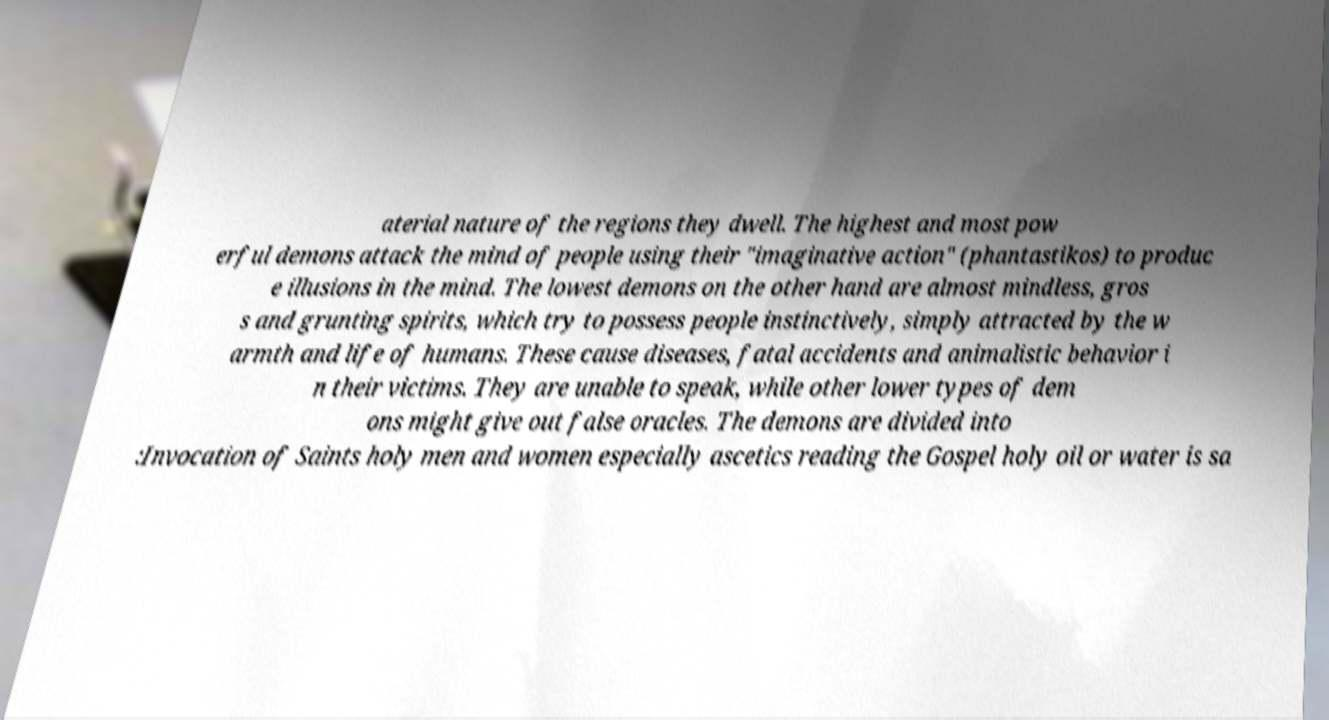What messages or text are displayed in this image? I need them in a readable, typed format. aterial nature of the regions they dwell. The highest and most pow erful demons attack the mind of people using their "imaginative action" (phantastikos) to produc e illusions in the mind. The lowest demons on the other hand are almost mindless, gros s and grunting spirits, which try to possess people instinctively, simply attracted by the w armth and life of humans. These cause diseases, fatal accidents and animalistic behavior i n their victims. They are unable to speak, while other lower types of dem ons might give out false oracles. The demons are divided into :Invocation of Saints holy men and women especially ascetics reading the Gospel holy oil or water is sa 